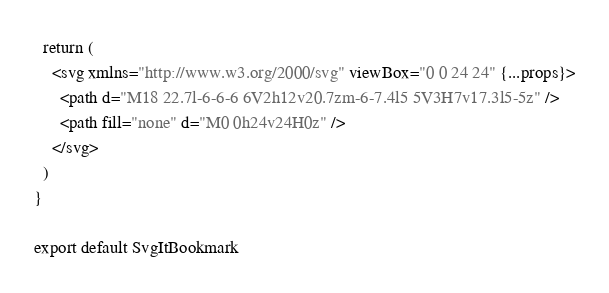<code> <loc_0><loc_0><loc_500><loc_500><_JavaScript_>  return (
    <svg xmlns="http://www.w3.org/2000/svg" viewBox="0 0 24 24" {...props}>
      <path d="M18 22.7l-6-6-6 6V2h12v20.7zm-6-7.4l5 5V3H7v17.3l5-5z" />
      <path fill="none" d="M0 0h24v24H0z" />
    </svg>
  )
}

export default SvgItBookmark
</code> 